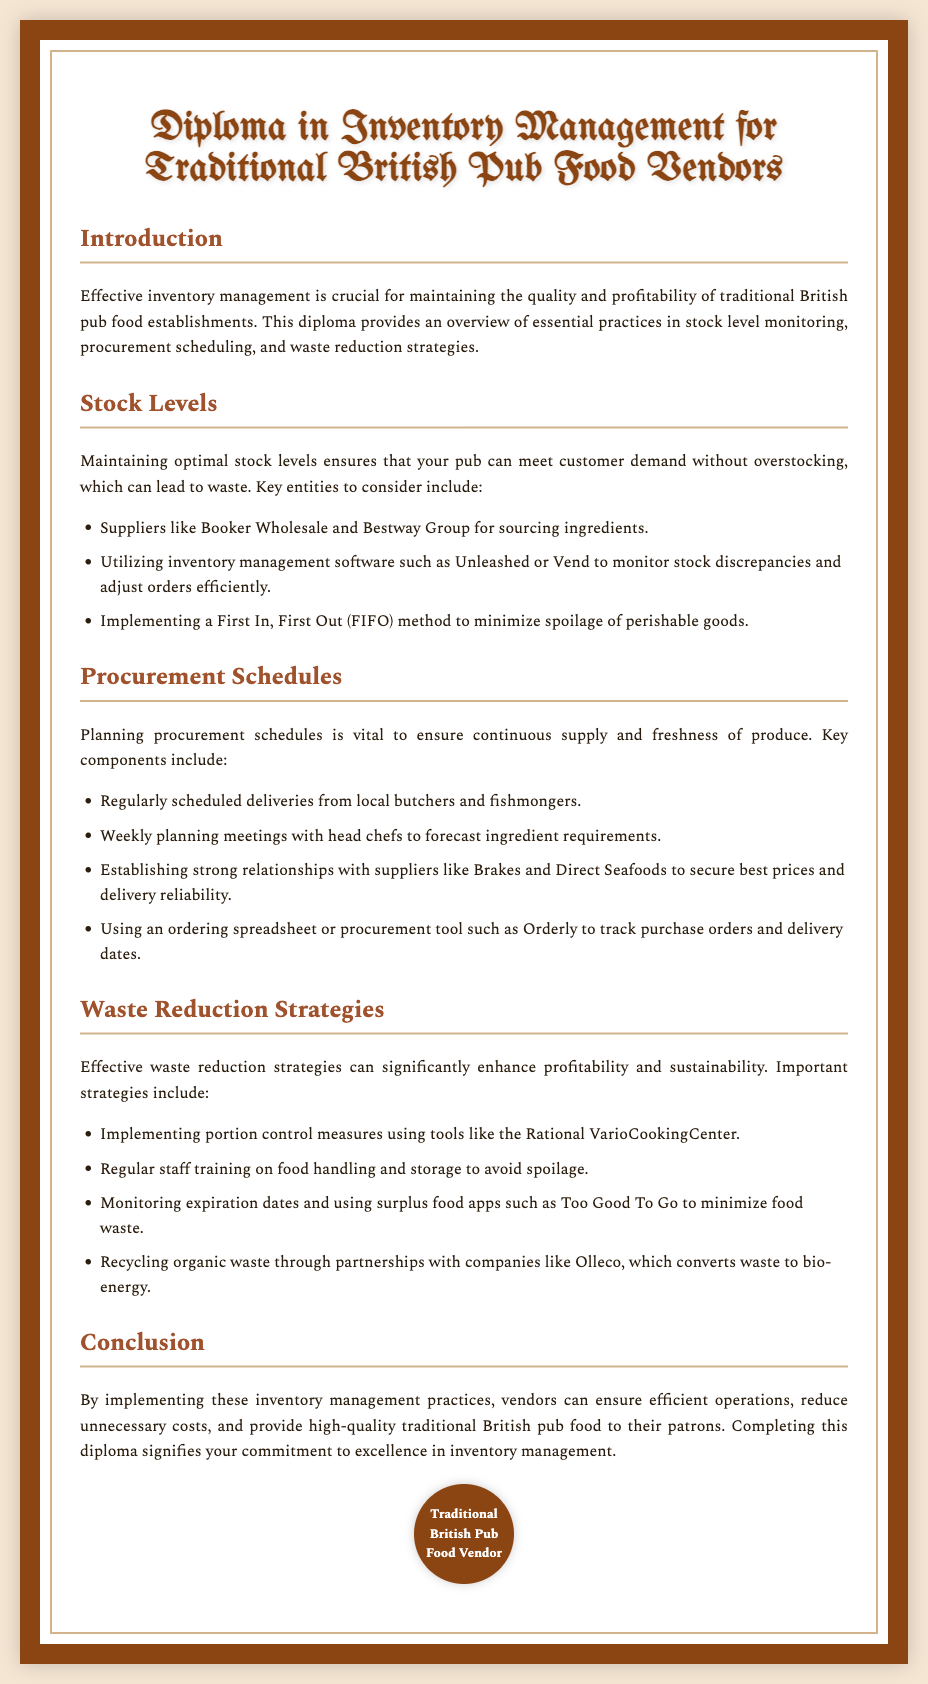What is the title of the diploma? The title is specifically mentioned at the top of the document and is "Diploma in Inventory Management for Traditional British Pub Food Vendors."
Answer: Diploma in Inventory Management for Traditional British Pub Food Vendors What is a key supplier mentioned for sourcing ingredients? The document lists "Booker Wholesale" as one of the suppliers for sourcing ingredients.
Answer: Booker Wholesale What method is suggested to minimize spoilage of perishable goods? The document recommends the First In, First Out (FIFO) method to manage stock effectively.
Answer: First In, First Out (FIFO) What tool is mentioned for tracking procurement orders? The document specifies "Orderly" as a procurement tool to keep track of purchase orders and delivery dates.
Answer: Orderly What is one strategy for reducing food waste? One strategy highlighted is using portion control measures with the Rational VarioCookingCenter.
Answer: portion control measures What is identified as a key component of procurement schedules? The document suggests having "weekly planning meetings" with head chefs to forecast ingredient requirements regularly.
Answer: weekly planning meetings How does the document describe the importance of inventory management? It states that effective inventory management is crucial for maintaining quality and profitability in food establishments.
Answer: maintaining quality and profitability What does completing this diploma signify? The document concludes that completing the diploma signifies a commitment to excellence in inventory management.
Answer: commitment to excellence 